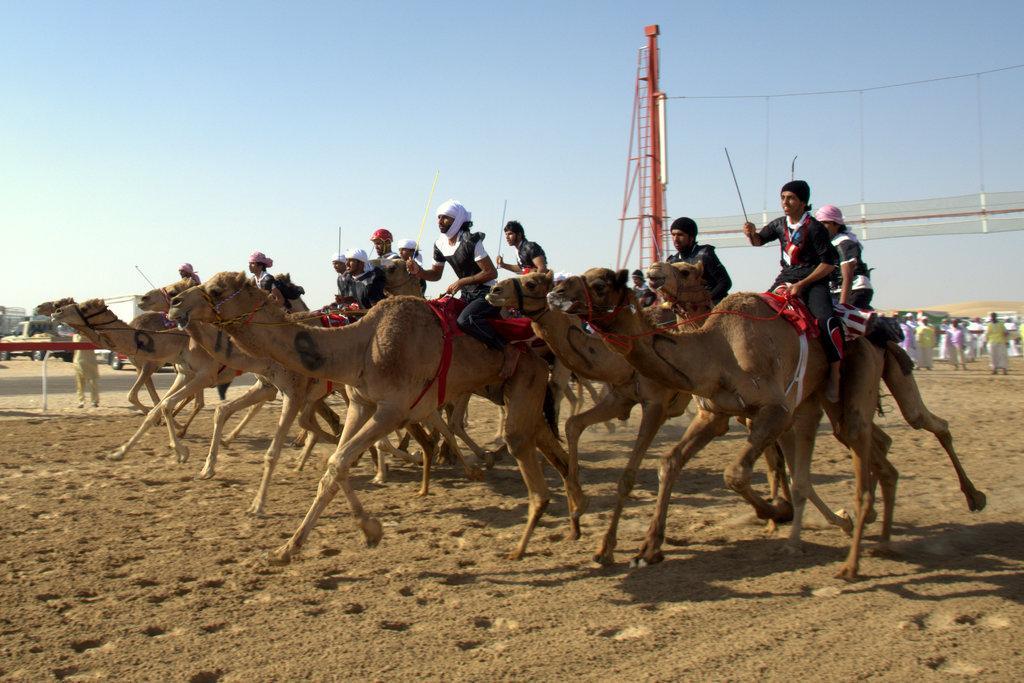How would you summarize this image in a sentence or two? In this picture we can see there is a group of people riding the camels on the path and behind the camel's there are groups of people and some vehicles. Behind the people there is a sky. 